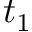Convert formula to latex. <formula><loc_0><loc_0><loc_500><loc_500>t _ { 1 }</formula> 